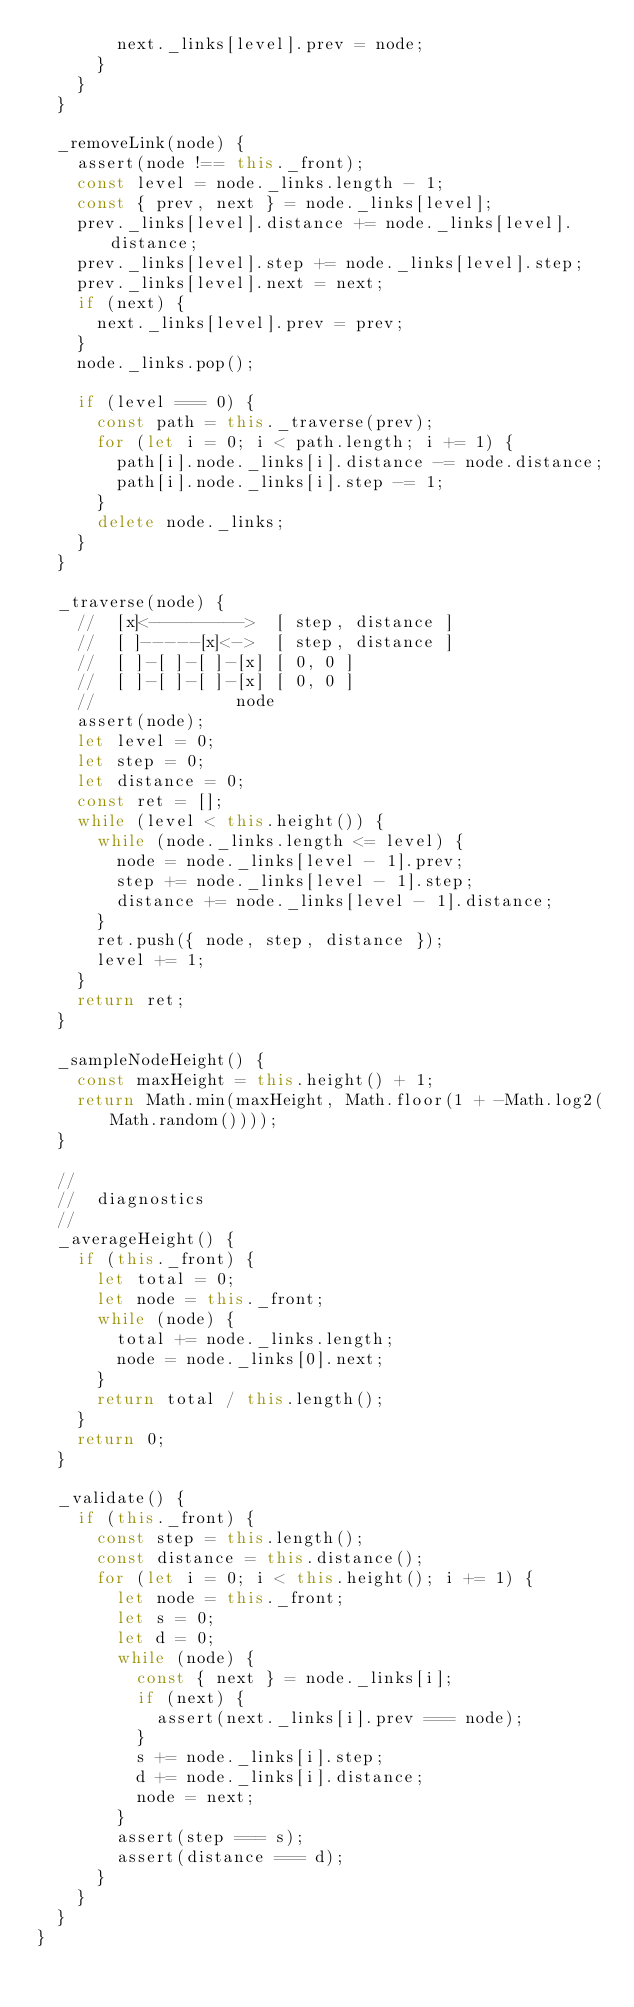Convert code to text. <code><loc_0><loc_0><loc_500><loc_500><_JavaScript_>        next._links[level].prev = node;
      }
    }
  }

  _removeLink(node) {
    assert(node !== this._front);
    const level = node._links.length - 1;
    const { prev, next } = node._links[level];
    prev._links[level].distance += node._links[level].distance;
    prev._links[level].step += node._links[level].step;
    prev._links[level].next = next;
    if (next) {
      next._links[level].prev = prev;
    }
    node._links.pop();

    if (level === 0) {
      const path = this._traverse(prev);
      for (let i = 0; i < path.length; i += 1) {
        path[i].node._links[i].distance -= node.distance;
        path[i].node._links[i].step -= 1;
      }
      delete node._links;
    }
  }

  _traverse(node) {
    //  [x]<--------->  [ step, distance ]
    //  [ ]-----[x]<->  [ step, distance ]
    //  [ ]-[ ]-[ ]-[x] [ 0, 0 ]
    //  [ ]-[ ]-[ ]-[x] [ 0, 0 ]
    //              node
    assert(node);
    let level = 0;
    let step = 0;
    let distance = 0;
    const ret = [];
    while (level < this.height()) {
      while (node._links.length <= level) {
        node = node._links[level - 1].prev;
        step += node._links[level - 1].step;
        distance += node._links[level - 1].distance;
      }
      ret.push({ node, step, distance });
      level += 1;
    }
    return ret;
  }

  _sampleNodeHeight() {
    const maxHeight = this.height() + 1;
    return Math.min(maxHeight, Math.floor(1 + -Math.log2(Math.random())));
  }

  //
  //  diagnostics
  //
  _averageHeight() {
    if (this._front) {
      let total = 0;
      let node = this._front;
      while (node) {
        total += node._links.length;
        node = node._links[0].next;
      }
      return total / this.length();
    }
    return 0;
  }

  _validate() {
    if (this._front) {
      const step = this.length();
      const distance = this.distance();
      for (let i = 0; i < this.height(); i += 1) {
        let node = this._front;
        let s = 0;
        let d = 0;
        while (node) {
          const { next } = node._links[i];
          if (next) {
            assert(next._links[i].prev === node);
          }
          s += node._links[i].step;
          d += node._links[i].distance;
          node = next;
        }
        assert(step === s);
        assert(distance === d);
      }
    }
  }
}
</code> 